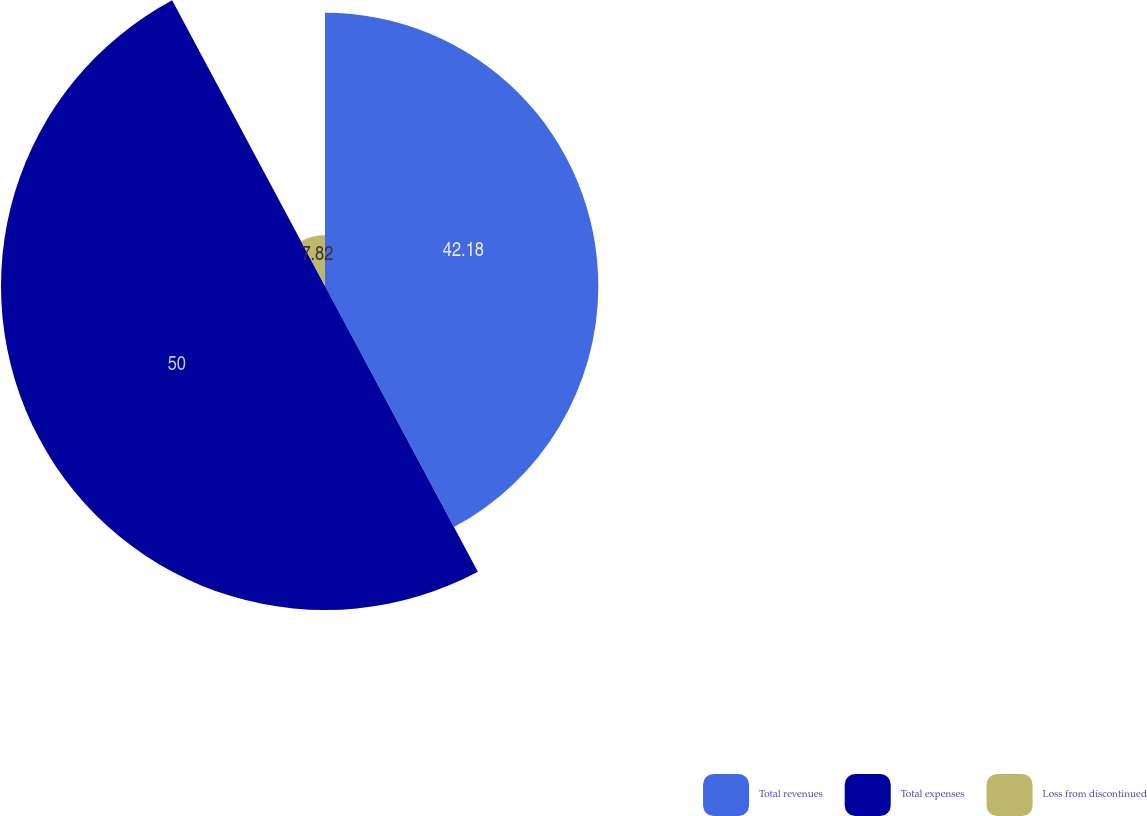Convert chart. <chart><loc_0><loc_0><loc_500><loc_500><pie_chart><fcel>Total revenues<fcel>Total expenses<fcel>Loss from discontinued<nl><fcel>42.18%<fcel>50.0%<fcel>7.82%<nl></chart> 